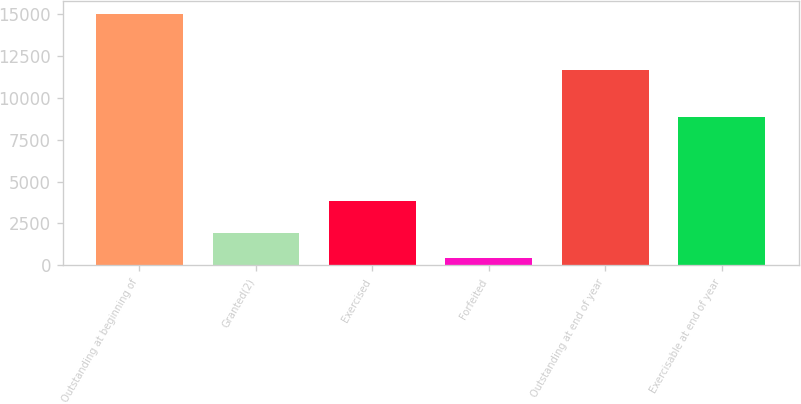Convert chart to OTSL. <chart><loc_0><loc_0><loc_500><loc_500><bar_chart><fcel>Outstanding at beginning of<fcel>Granted(2)<fcel>Exercised<fcel>Forfeited<fcel>Outstanding at end of year<fcel>Exercisable at end of year<nl><fcel>15011<fcel>1906.1<fcel>3825<fcel>450<fcel>11676<fcel>8838<nl></chart> 